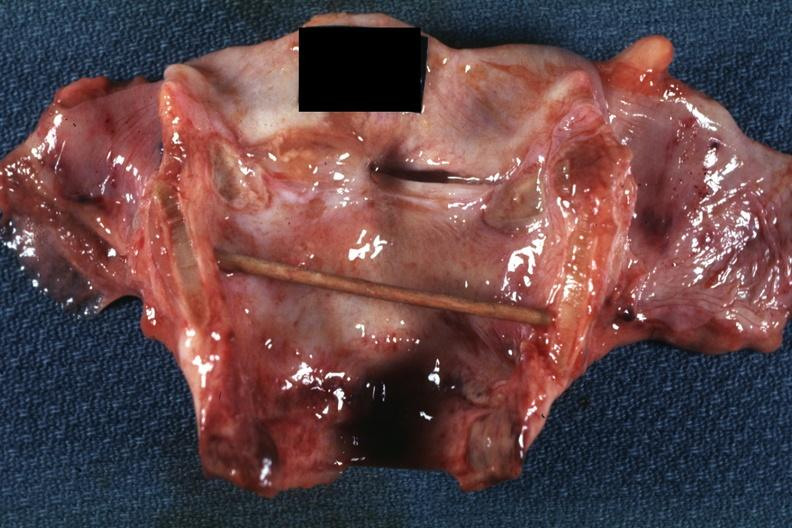where is this?
Answer the question using a single word or phrase. Oral 